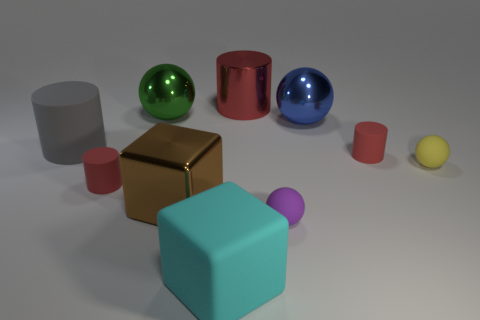Subtract all large blue metallic spheres. How many spheres are left? 3 Subtract all green balls. How many balls are left? 3 Subtract all cylinders. How many objects are left? 6 Subtract all yellow cubes. Subtract all yellow balls. How many cubes are left? 2 Subtract all gray blocks. How many gray cylinders are left? 1 Subtract all rubber things. Subtract all big gray rubber objects. How many objects are left? 3 Add 8 small red things. How many small red things are left? 10 Add 2 shiny things. How many shiny things exist? 6 Subtract 0 gray spheres. How many objects are left? 10 